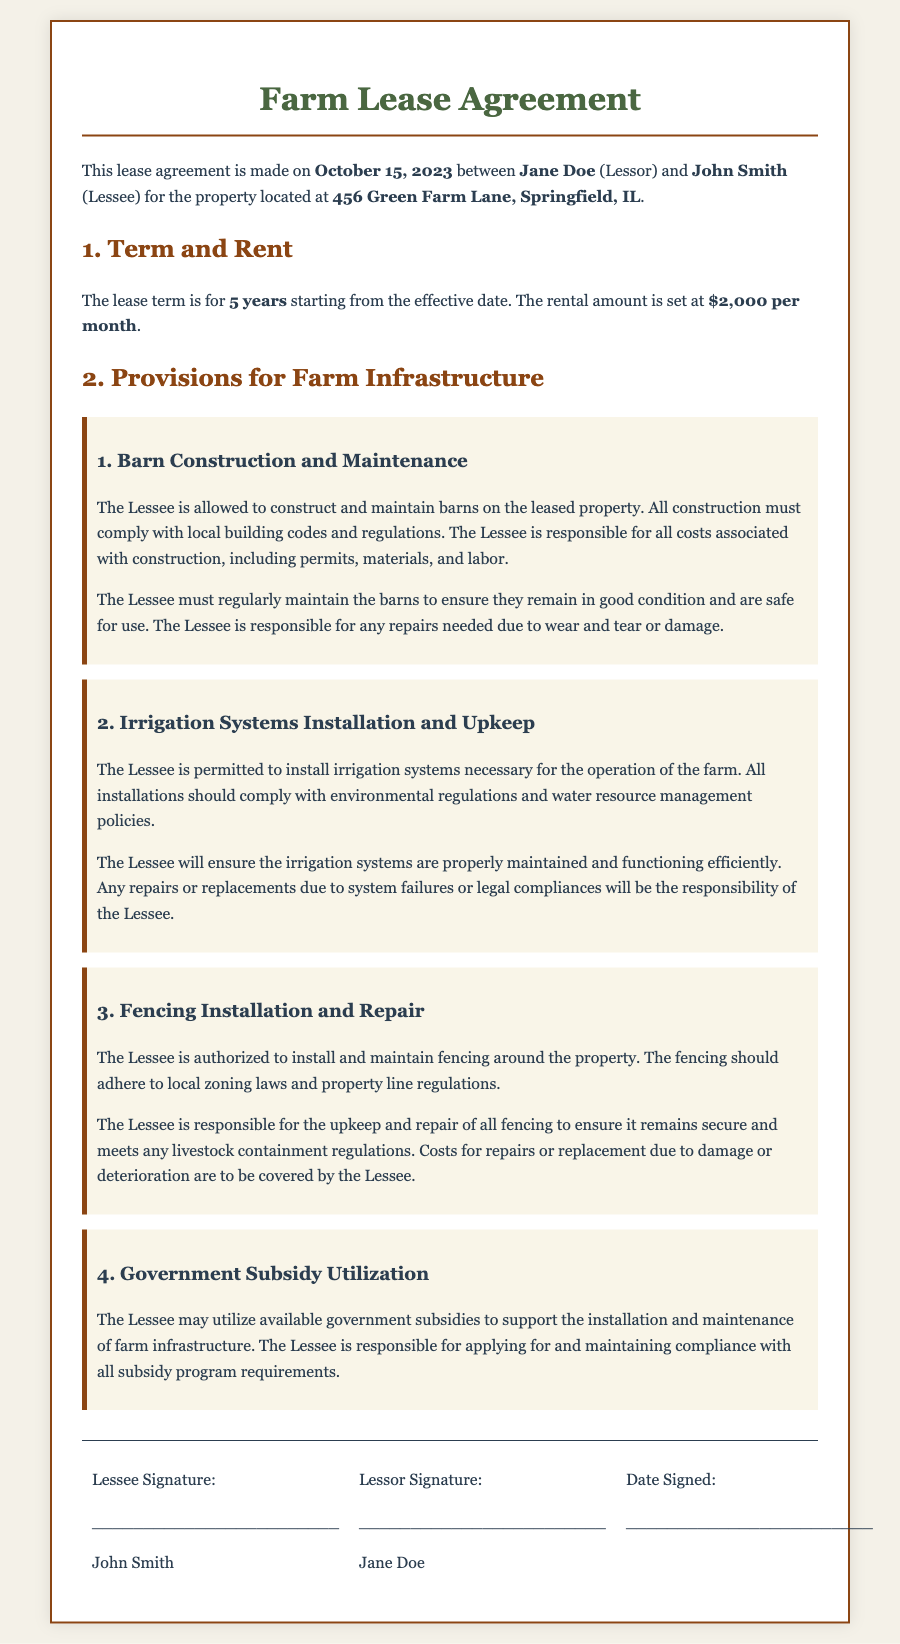What is the rental amount? The rental amount is specified in the document under the "Term and Rent" section.
Answer: $2,000 per month Who is the Lessor's name? The Lessor's name is mentioned at the beginning of the document as part of the lease agreement.
Answer: Jane Doe How long is the lease term? The lease term is stated in the "Term and Rent" section of the document.
Answer: 5 years What is the Lessee required to maintain? The document outlines various items that the Lessee is responsible for maintaining, particularly in the "Provisions for Farm Infrastructure" section.
Answer: Barns, irrigation systems, fencing What must all barn constructions comply with? The requirement is specified under the "Barn Construction and Maintenance" section of the document.
Answer: Local building codes and regulations What is the responsibility of the Lessee regarding government subsidies? The responsibility is outlined in the "Government Subsidy Utilization" provision.
Answer: Apply for and maintain compliance What should fencing adhere to? The document requires fencing to comply with specific regulations mentioned in the "Fencing Installation and Repair" section.
Answer: Local zoning laws and property line regulations What is the Lessee responsible for in terms of irrigation systems? The document specifies the Lessee's responsibility concerning irrigation systems under a dedicated provision.
Answer: Maintenance and repairs 